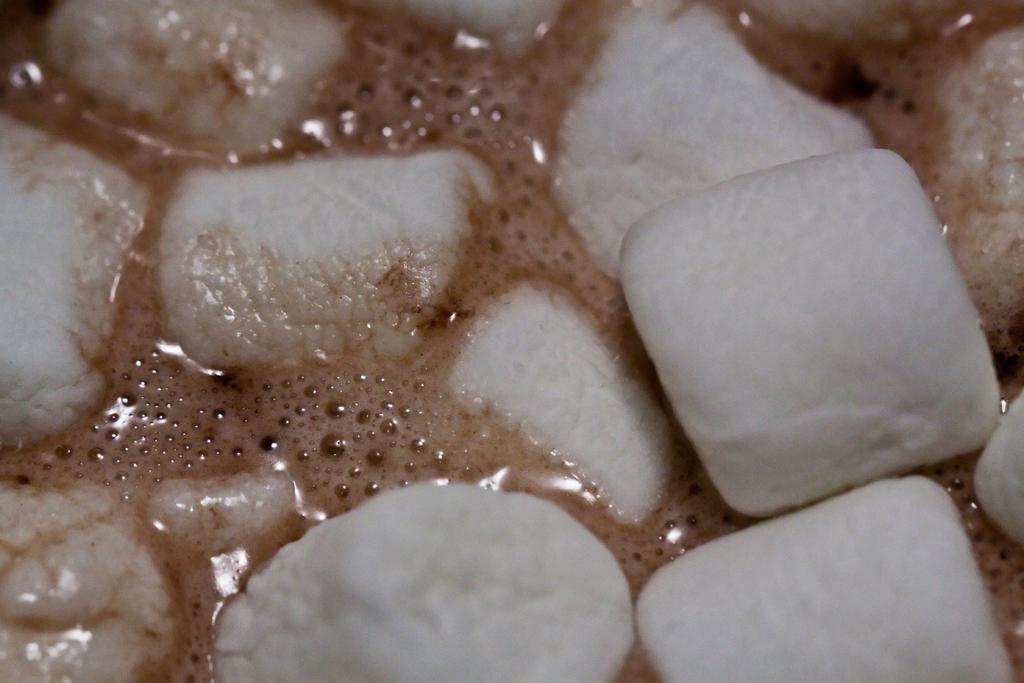What is the main subject of the image? There is a food item in the image. How does the food item blow in the image? The food item does not blow in the image; there is no indication of any movement or blowing. 